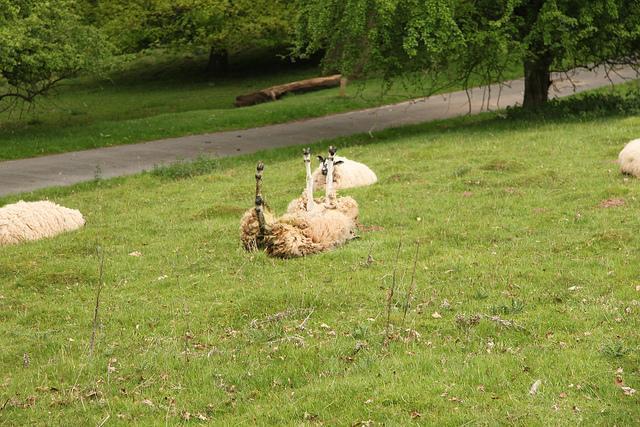How many sheep are in the picture?
Give a very brief answer. 2. How many people are wearing denim pants?
Give a very brief answer. 0. 